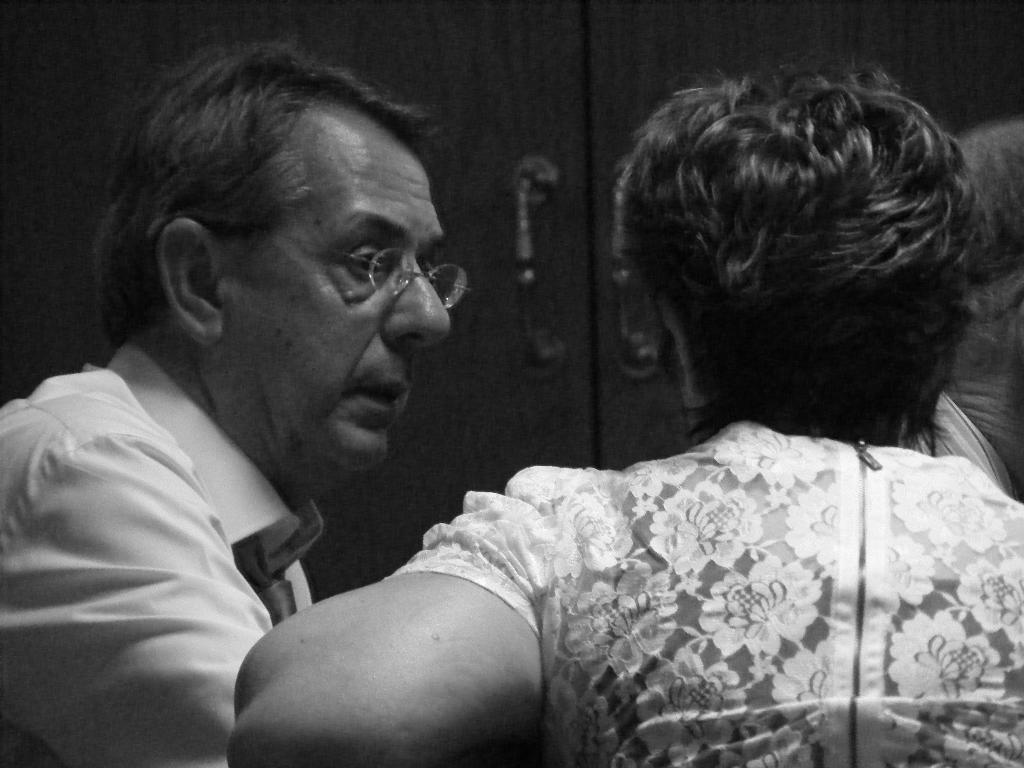Could you give a brief overview of what you see in this image? Here in this picture we can see a man and a woman sitting over a place and we can see the man is wearing spectacles and speaking something and in front of them we can see a door present. 